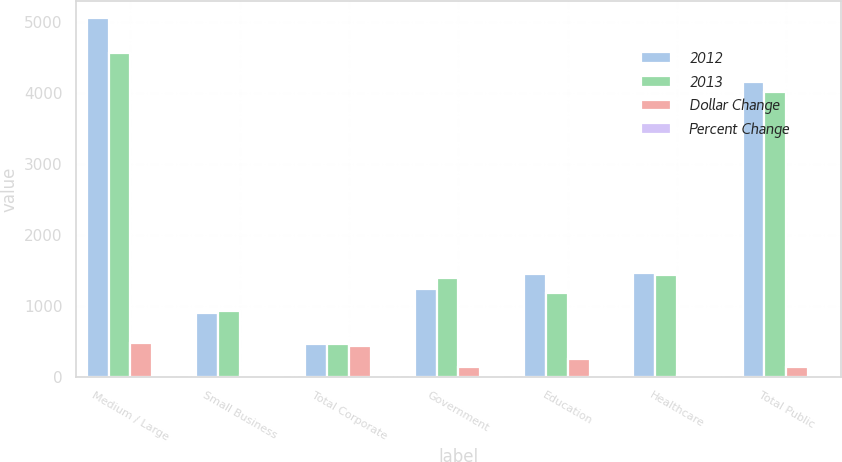Convert chart to OTSL. <chart><loc_0><loc_0><loc_500><loc_500><stacked_bar_chart><ecel><fcel>Medium / Large<fcel>Small Business<fcel>Total Corporate<fcel>Government<fcel>Education<fcel>Healthcare<fcel>Total Public<nl><fcel>2012<fcel>5052.7<fcel>907.4<fcel>463.65<fcel>1250.6<fcel>1449<fcel>1464.9<fcel>4164.5<nl><fcel>2013<fcel>4572.7<fcel>940.1<fcel>463.65<fcel>1394.1<fcel>1192.3<fcel>1436.6<fcel>4023<nl><fcel>Dollar Change<fcel>480<fcel>32.7<fcel>447.3<fcel>143.5<fcel>256.7<fcel>28.3<fcel>141.5<nl><fcel>Percent Change<fcel>10.5<fcel>3.5<fcel>8.1<fcel>10.3<fcel>21.5<fcel>2<fcel>3.5<nl></chart> 